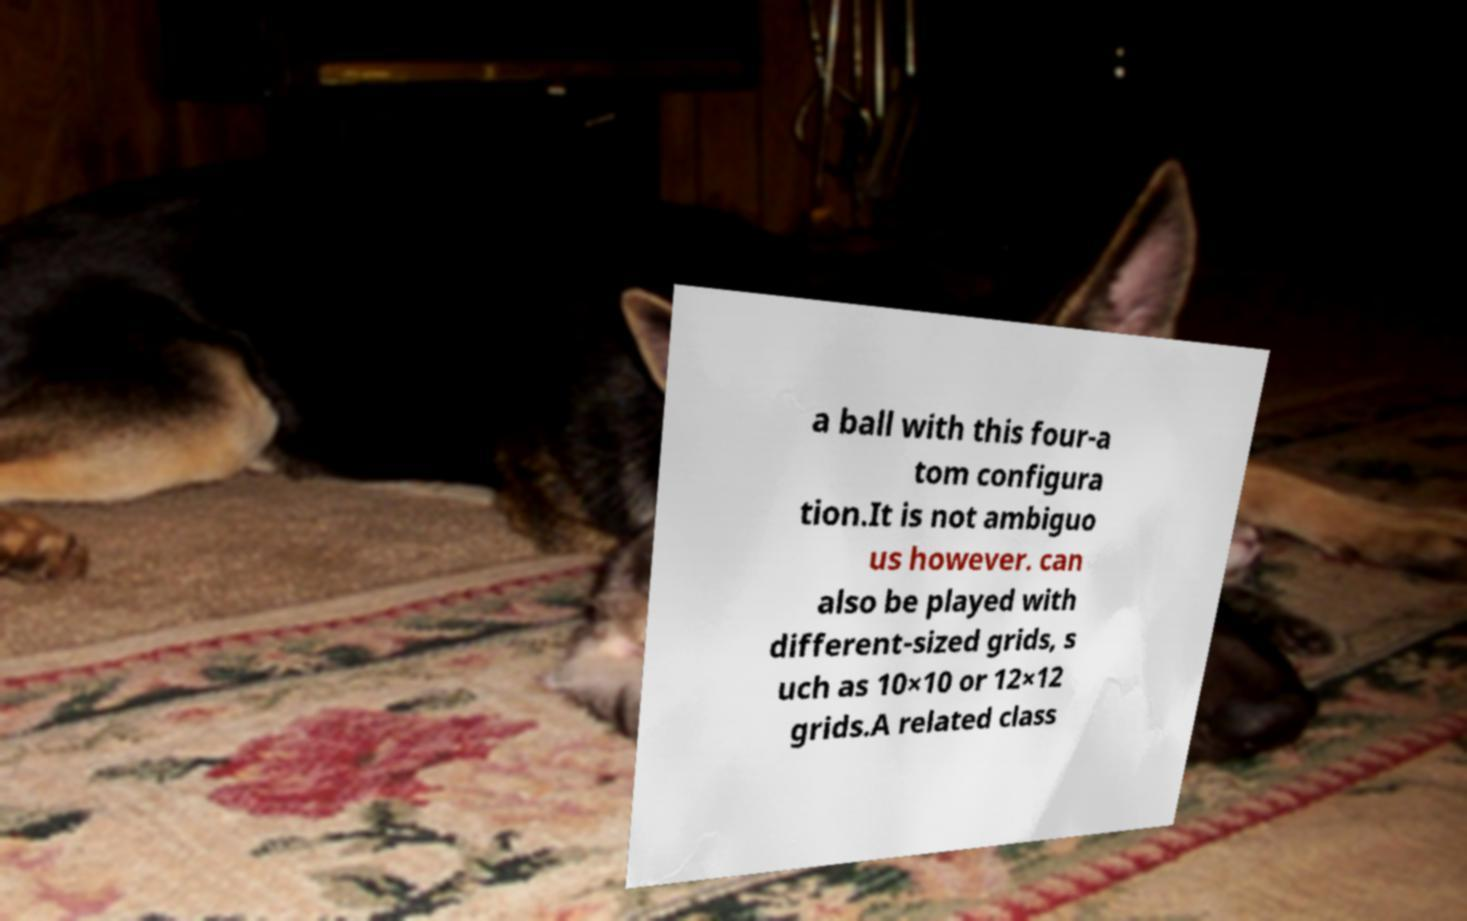Can you accurately transcribe the text from the provided image for me? a ball with this four-a tom configura tion.It is not ambiguo us however. can also be played with different-sized grids, s uch as 10×10 or 12×12 grids.A related class 